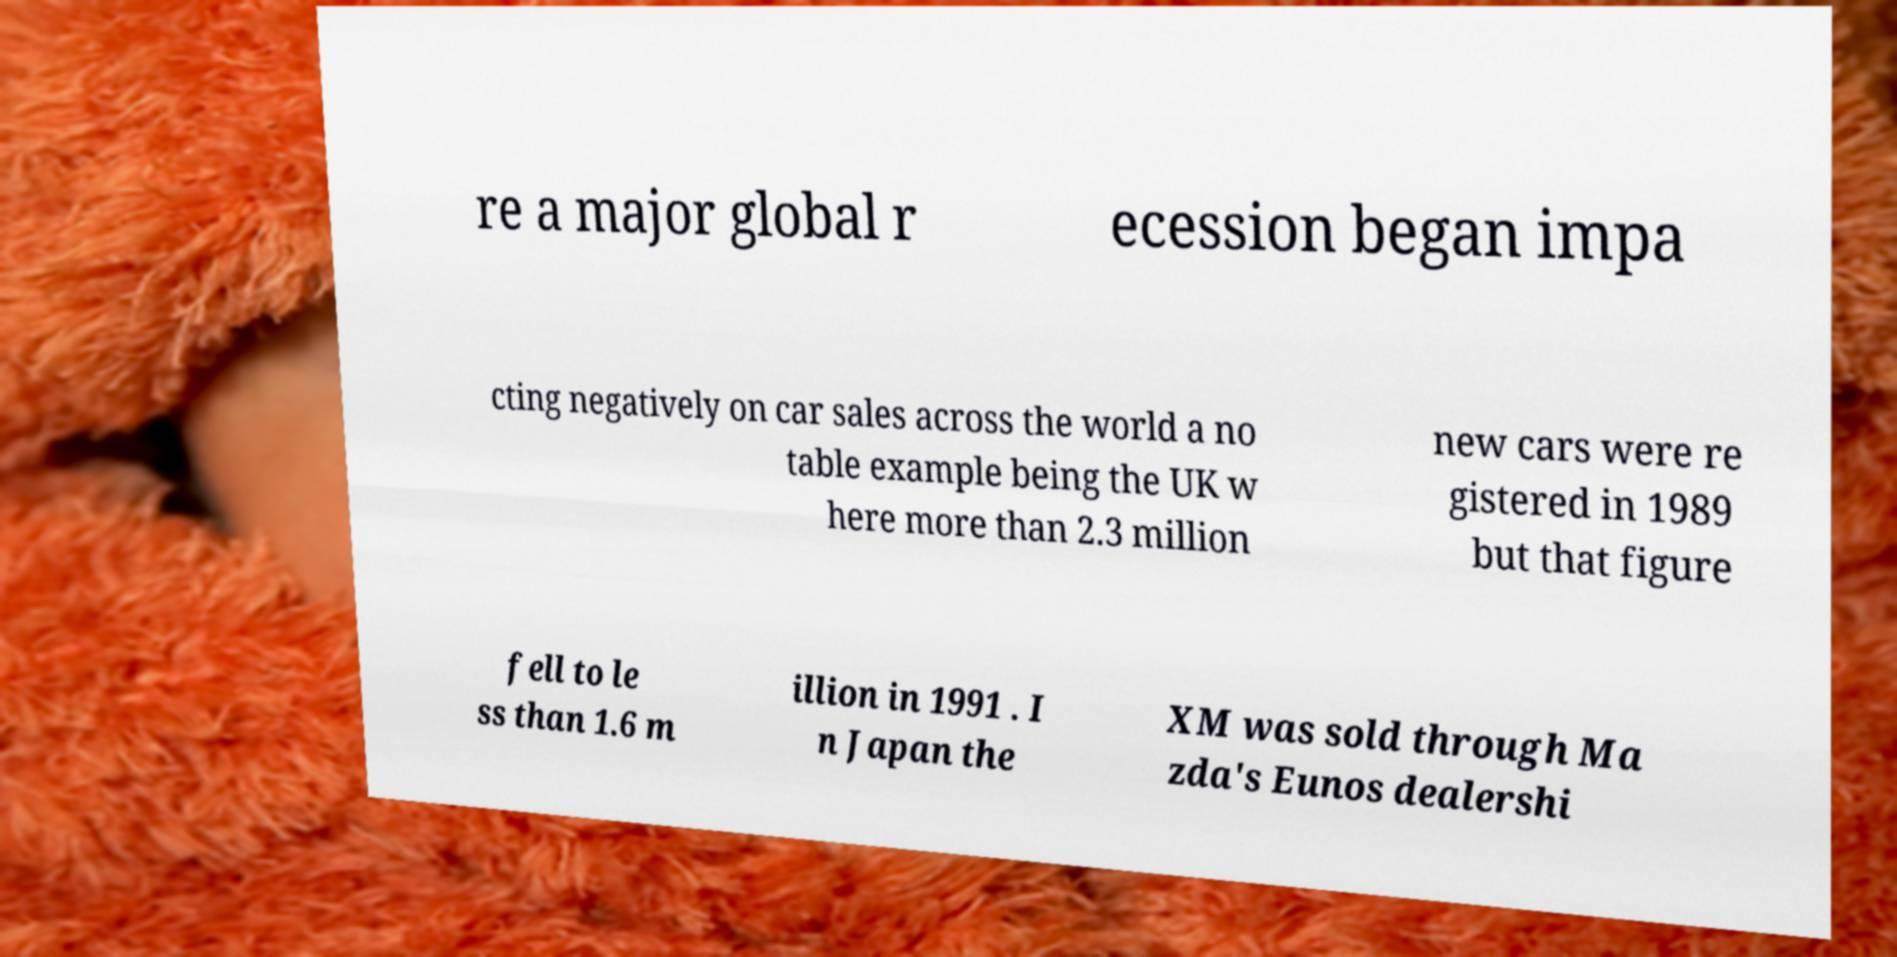Please read and relay the text visible in this image. What does it say? re a major global r ecession began impa cting negatively on car sales across the world a no table example being the UK w here more than 2.3 million new cars were re gistered in 1989 but that figure fell to le ss than 1.6 m illion in 1991 . I n Japan the XM was sold through Ma zda's Eunos dealershi 